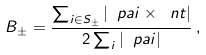<formula> <loc_0><loc_0><loc_500><loc_500>B _ { \pm } = \frac { \sum _ { i \in { S } _ { \pm } } | \ p a i \times \ n t | } { 2 \sum _ { i } | \ p a i | } \, ,</formula> 